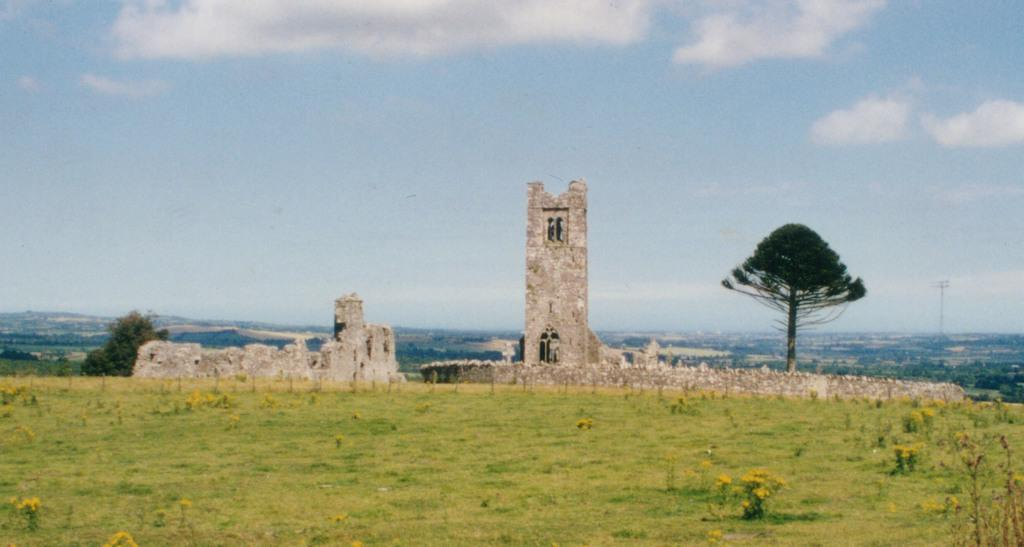What type of structure is present in the image? There is a fort in the image. What is another feature visible in the image? There is a wall in the image. What can be seen in the background of the image? There are plants, trees, and the sky visible in the background of the image. What type of pen can be seen in the wilderness in the image? There is no pen or wilderness present in the image; it features a fort, a wall, and natural elements in the background. 